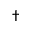Convert formula to latex. <formula><loc_0><loc_0><loc_500><loc_500>\dagger</formula> 